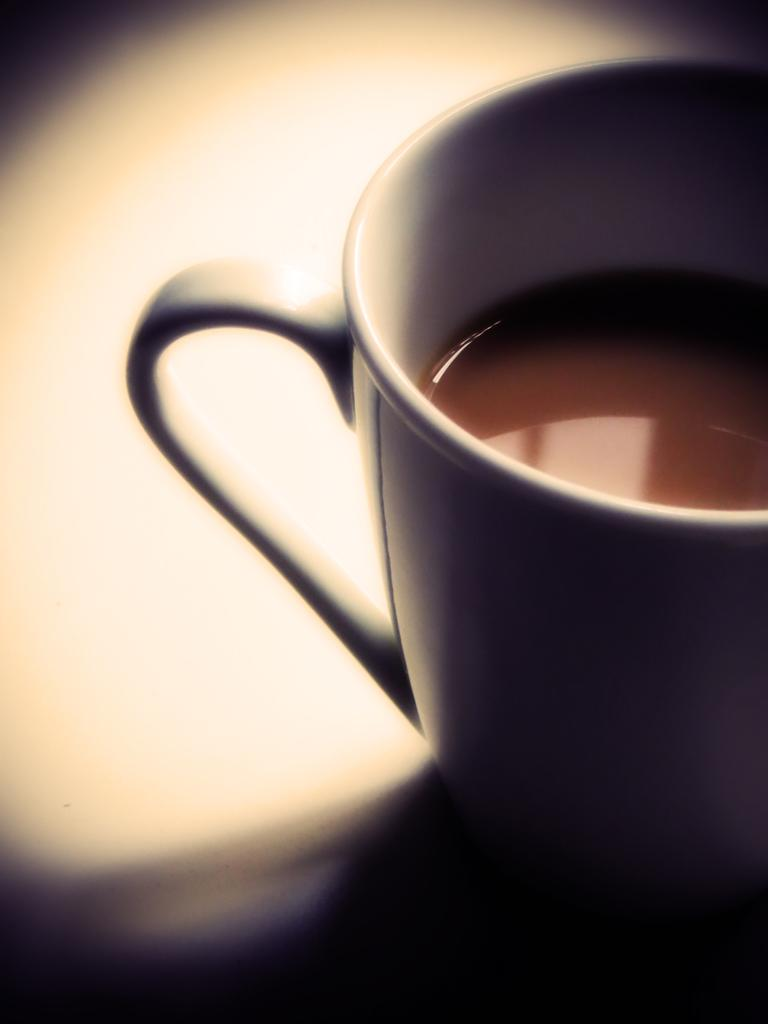What is the main object in the image? There is a teacup in the image. What color is the teacup? The teacup is white in color. Can you hear the teacup crying in the image? The image does not contain any sounds, and teacups do not have the ability to cry. 